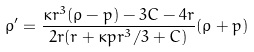Convert formula to latex. <formula><loc_0><loc_0><loc_500><loc_500>\rho ^ { \prime } = \frac { \kappa r ^ { 3 } ( \rho - p ) - 3 C - 4 r } { 2 r ( r + \kappa p r ^ { 3 } / 3 + C ) } ( \rho + p )</formula> 